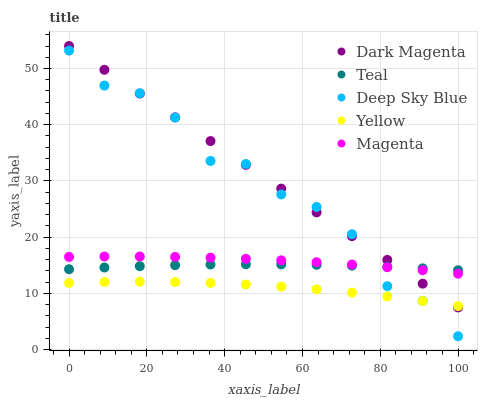Does Yellow have the minimum area under the curve?
Answer yes or no. Yes. Does Dark Magenta have the maximum area under the curve?
Answer yes or no. Yes. Does Magenta have the minimum area under the curve?
Answer yes or no. No. Does Magenta have the maximum area under the curve?
Answer yes or no. No. Is Dark Magenta the smoothest?
Answer yes or no. Yes. Is Deep Sky Blue the roughest?
Answer yes or no. Yes. Is Magenta the smoothest?
Answer yes or no. No. Is Magenta the roughest?
Answer yes or no. No. Does Deep Sky Blue have the lowest value?
Answer yes or no. Yes. Does Magenta have the lowest value?
Answer yes or no. No. Does Dark Magenta have the highest value?
Answer yes or no. Yes. Does Magenta have the highest value?
Answer yes or no. No. Is Yellow less than Teal?
Answer yes or no. Yes. Is Teal greater than Yellow?
Answer yes or no. Yes. Does Magenta intersect Dark Magenta?
Answer yes or no. Yes. Is Magenta less than Dark Magenta?
Answer yes or no. No. Is Magenta greater than Dark Magenta?
Answer yes or no. No. Does Yellow intersect Teal?
Answer yes or no. No. 